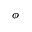<formula> <loc_0><loc_0><loc_500><loc_500>\phi</formula> 